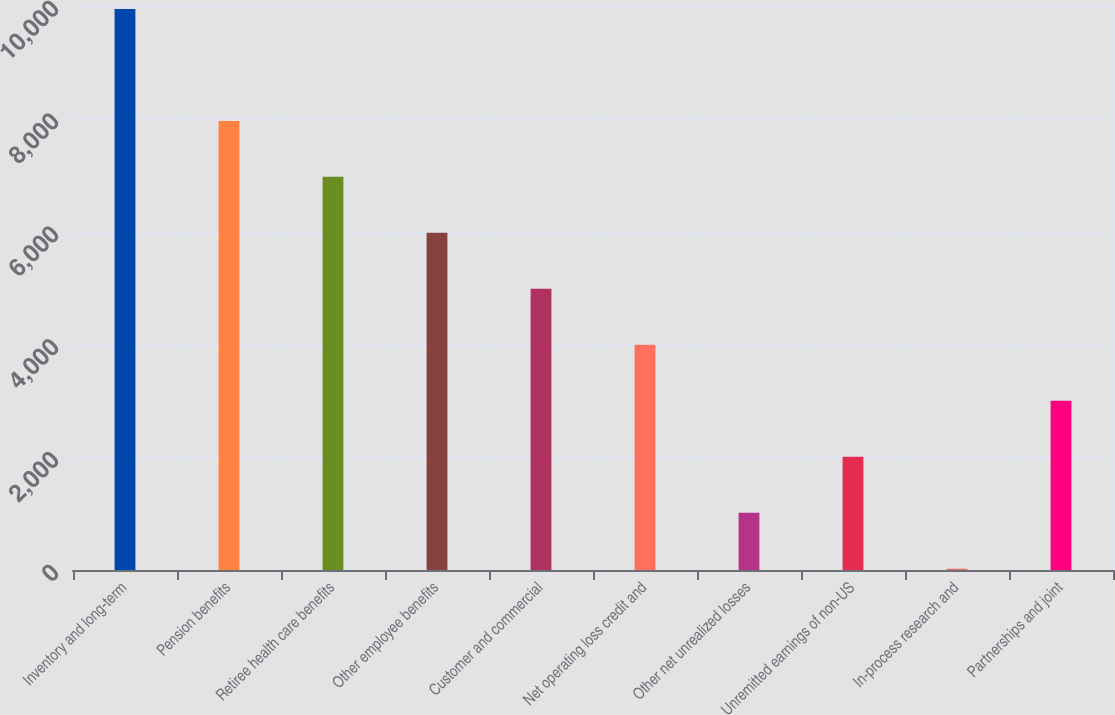Convert chart. <chart><loc_0><loc_0><loc_500><loc_500><bar_chart><fcel>Inventory and long-term<fcel>Pension benefits<fcel>Retiree health care benefits<fcel>Other employee benefits<fcel>Customer and commercial<fcel>Net operating loss credit and<fcel>Other net unrealized losses<fcel>Unremitted earnings of non-US<fcel>In-process research and<fcel>Partnerships and joint<nl><fcel>9948<fcel>7963<fcel>6970.5<fcel>5978<fcel>4985.5<fcel>3993<fcel>1015.5<fcel>2008<fcel>23<fcel>3000.5<nl></chart> 